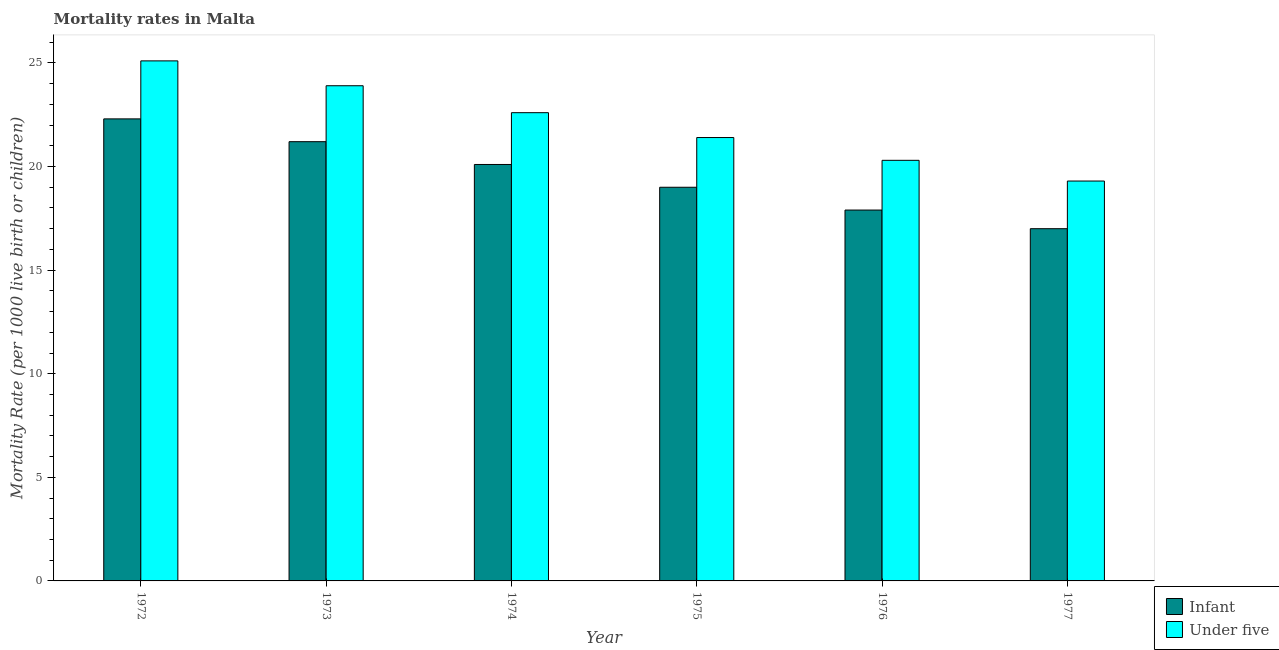How many different coloured bars are there?
Keep it short and to the point. 2. Are the number of bars per tick equal to the number of legend labels?
Provide a succinct answer. Yes. Are the number of bars on each tick of the X-axis equal?
Your answer should be very brief. Yes. How many bars are there on the 1st tick from the left?
Provide a succinct answer. 2. What is the label of the 6th group of bars from the left?
Offer a very short reply. 1977. Across all years, what is the maximum infant mortality rate?
Offer a very short reply. 22.3. Across all years, what is the minimum under-5 mortality rate?
Keep it short and to the point. 19.3. In which year was the infant mortality rate minimum?
Your response must be concise. 1977. What is the total under-5 mortality rate in the graph?
Your response must be concise. 132.6. What is the difference between the under-5 mortality rate in 1973 and that in 1975?
Ensure brevity in your answer.  2.5. What is the difference between the under-5 mortality rate in 1976 and the infant mortality rate in 1972?
Make the answer very short. -4.8. What is the average infant mortality rate per year?
Provide a short and direct response. 19.58. What is the ratio of the under-5 mortality rate in 1975 to that in 1976?
Make the answer very short. 1.05. Is the difference between the under-5 mortality rate in 1973 and 1974 greater than the difference between the infant mortality rate in 1973 and 1974?
Your answer should be very brief. No. What is the difference between the highest and the second highest under-5 mortality rate?
Provide a short and direct response. 1.2. What is the difference between the highest and the lowest infant mortality rate?
Make the answer very short. 5.3. Is the sum of the under-5 mortality rate in 1973 and 1977 greater than the maximum infant mortality rate across all years?
Give a very brief answer. Yes. What does the 2nd bar from the left in 1975 represents?
Offer a terse response. Under five. What does the 1st bar from the right in 1975 represents?
Offer a very short reply. Under five. How many bars are there?
Keep it short and to the point. 12. Are all the bars in the graph horizontal?
Make the answer very short. No. Where does the legend appear in the graph?
Your answer should be very brief. Bottom right. What is the title of the graph?
Provide a succinct answer. Mortality rates in Malta. Does "Techinal cooperation" appear as one of the legend labels in the graph?
Provide a short and direct response. No. What is the label or title of the Y-axis?
Your answer should be very brief. Mortality Rate (per 1000 live birth or children). What is the Mortality Rate (per 1000 live birth or children) in Infant in 1972?
Your response must be concise. 22.3. What is the Mortality Rate (per 1000 live birth or children) in Under five in 1972?
Give a very brief answer. 25.1. What is the Mortality Rate (per 1000 live birth or children) in Infant in 1973?
Keep it short and to the point. 21.2. What is the Mortality Rate (per 1000 live birth or children) in Under five in 1973?
Your answer should be very brief. 23.9. What is the Mortality Rate (per 1000 live birth or children) of Infant in 1974?
Ensure brevity in your answer.  20.1. What is the Mortality Rate (per 1000 live birth or children) in Under five in 1974?
Make the answer very short. 22.6. What is the Mortality Rate (per 1000 live birth or children) of Infant in 1975?
Provide a succinct answer. 19. What is the Mortality Rate (per 1000 live birth or children) of Under five in 1975?
Your answer should be compact. 21.4. What is the Mortality Rate (per 1000 live birth or children) of Under five in 1976?
Provide a succinct answer. 20.3. What is the Mortality Rate (per 1000 live birth or children) in Under five in 1977?
Offer a terse response. 19.3. Across all years, what is the maximum Mortality Rate (per 1000 live birth or children) in Infant?
Give a very brief answer. 22.3. Across all years, what is the maximum Mortality Rate (per 1000 live birth or children) in Under five?
Provide a succinct answer. 25.1. Across all years, what is the minimum Mortality Rate (per 1000 live birth or children) of Infant?
Your answer should be compact. 17. Across all years, what is the minimum Mortality Rate (per 1000 live birth or children) in Under five?
Your answer should be compact. 19.3. What is the total Mortality Rate (per 1000 live birth or children) of Infant in the graph?
Keep it short and to the point. 117.5. What is the total Mortality Rate (per 1000 live birth or children) in Under five in the graph?
Make the answer very short. 132.6. What is the difference between the Mortality Rate (per 1000 live birth or children) of Under five in 1972 and that in 1975?
Offer a very short reply. 3.7. What is the difference between the Mortality Rate (per 1000 live birth or children) in Infant in 1972 and that in 1977?
Ensure brevity in your answer.  5.3. What is the difference between the Mortality Rate (per 1000 live birth or children) in Under five in 1972 and that in 1977?
Give a very brief answer. 5.8. What is the difference between the Mortality Rate (per 1000 live birth or children) of Infant in 1973 and that in 1976?
Make the answer very short. 3.3. What is the difference between the Mortality Rate (per 1000 live birth or children) in Under five in 1973 and that in 1976?
Ensure brevity in your answer.  3.6. What is the difference between the Mortality Rate (per 1000 live birth or children) in Infant in 1973 and that in 1977?
Offer a very short reply. 4.2. What is the difference between the Mortality Rate (per 1000 live birth or children) of Infant in 1974 and that in 1976?
Offer a very short reply. 2.2. What is the difference between the Mortality Rate (per 1000 live birth or children) in Infant in 1974 and that in 1977?
Your answer should be compact. 3.1. What is the difference between the Mortality Rate (per 1000 live birth or children) of Infant in 1975 and that in 1976?
Your answer should be compact. 1.1. What is the difference between the Mortality Rate (per 1000 live birth or children) of Under five in 1975 and that in 1976?
Provide a succinct answer. 1.1. What is the difference between the Mortality Rate (per 1000 live birth or children) of Infant in 1972 and the Mortality Rate (per 1000 live birth or children) of Under five in 1974?
Make the answer very short. -0.3. What is the difference between the Mortality Rate (per 1000 live birth or children) in Infant in 1972 and the Mortality Rate (per 1000 live birth or children) in Under five in 1976?
Offer a very short reply. 2. What is the difference between the Mortality Rate (per 1000 live birth or children) in Infant in 1972 and the Mortality Rate (per 1000 live birth or children) in Under five in 1977?
Your response must be concise. 3. What is the difference between the Mortality Rate (per 1000 live birth or children) in Infant in 1974 and the Mortality Rate (per 1000 live birth or children) in Under five in 1975?
Make the answer very short. -1.3. What is the difference between the Mortality Rate (per 1000 live birth or children) in Infant in 1974 and the Mortality Rate (per 1000 live birth or children) in Under five in 1976?
Offer a terse response. -0.2. What is the difference between the Mortality Rate (per 1000 live birth or children) in Infant in 1975 and the Mortality Rate (per 1000 live birth or children) in Under five in 1976?
Offer a very short reply. -1.3. What is the difference between the Mortality Rate (per 1000 live birth or children) of Infant in 1975 and the Mortality Rate (per 1000 live birth or children) of Under five in 1977?
Ensure brevity in your answer.  -0.3. What is the average Mortality Rate (per 1000 live birth or children) of Infant per year?
Keep it short and to the point. 19.58. What is the average Mortality Rate (per 1000 live birth or children) of Under five per year?
Ensure brevity in your answer.  22.1. In the year 1974, what is the difference between the Mortality Rate (per 1000 live birth or children) of Infant and Mortality Rate (per 1000 live birth or children) of Under five?
Your answer should be very brief. -2.5. What is the ratio of the Mortality Rate (per 1000 live birth or children) in Infant in 1972 to that in 1973?
Your answer should be compact. 1.05. What is the ratio of the Mortality Rate (per 1000 live birth or children) of Under five in 1972 to that in 1973?
Your answer should be compact. 1.05. What is the ratio of the Mortality Rate (per 1000 live birth or children) in Infant in 1972 to that in 1974?
Make the answer very short. 1.11. What is the ratio of the Mortality Rate (per 1000 live birth or children) of Under five in 1972 to that in 1974?
Give a very brief answer. 1.11. What is the ratio of the Mortality Rate (per 1000 live birth or children) of Infant in 1972 to that in 1975?
Ensure brevity in your answer.  1.17. What is the ratio of the Mortality Rate (per 1000 live birth or children) in Under five in 1972 to that in 1975?
Offer a terse response. 1.17. What is the ratio of the Mortality Rate (per 1000 live birth or children) in Infant in 1972 to that in 1976?
Your answer should be compact. 1.25. What is the ratio of the Mortality Rate (per 1000 live birth or children) of Under five in 1972 to that in 1976?
Your answer should be very brief. 1.24. What is the ratio of the Mortality Rate (per 1000 live birth or children) of Infant in 1972 to that in 1977?
Your answer should be compact. 1.31. What is the ratio of the Mortality Rate (per 1000 live birth or children) in Under five in 1972 to that in 1977?
Your answer should be very brief. 1.3. What is the ratio of the Mortality Rate (per 1000 live birth or children) in Infant in 1973 to that in 1974?
Your answer should be compact. 1.05. What is the ratio of the Mortality Rate (per 1000 live birth or children) of Under five in 1973 to that in 1974?
Offer a very short reply. 1.06. What is the ratio of the Mortality Rate (per 1000 live birth or children) of Infant in 1973 to that in 1975?
Provide a succinct answer. 1.12. What is the ratio of the Mortality Rate (per 1000 live birth or children) of Under five in 1973 to that in 1975?
Offer a very short reply. 1.12. What is the ratio of the Mortality Rate (per 1000 live birth or children) of Infant in 1973 to that in 1976?
Make the answer very short. 1.18. What is the ratio of the Mortality Rate (per 1000 live birth or children) of Under five in 1973 to that in 1976?
Offer a terse response. 1.18. What is the ratio of the Mortality Rate (per 1000 live birth or children) of Infant in 1973 to that in 1977?
Keep it short and to the point. 1.25. What is the ratio of the Mortality Rate (per 1000 live birth or children) in Under five in 1973 to that in 1977?
Offer a terse response. 1.24. What is the ratio of the Mortality Rate (per 1000 live birth or children) in Infant in 1974 to that in 1975?
Your response must be concise. 1.06. What is the ratio of the Mortality Rate (per 1000 live birth or children) in Under five in 1974 to that in 1975?
Offer a terse response. 1.06. What is the ratio of the Mortality Rate (per 1000 live birth or children) of Infant in 1974 to that in 1976?
Keep it short and to the point. 1.12. What is the ratio of the Mortality Rate (per 1000 live birth or children) in Under five in 1974 to that in 1976?
Make the answer very short. 1.11. What is the ratio of the Mortality Rate (per 1000 live birth or children) in Infant in 1974 to that in 1977?
Ensure brevity in your answer.  1.18. What is the ratio of the Mortality Rate (per 1000 live birth or children) in Under five in 1974 to that in 1977?
Provide a succinct answer. 1.17. What is the ratio of the Mortality Rate (per 1000 live birth or children) in Infant in 1975 to that in 1976?
Your answer should be very brief. 1.06. What is the ratio of the Mortality Rate (per 1000 live birth or children) of Under five in 1975 to that in 1976?
Your answer should be very brief. 1.05. What is the ratio of the Mortality Rate (per 1000 live birth or children) in Infant in 1975 to that in 1977?
Your response must be concise. 1.12. What is the ratio of the Mortality Rate (per 1000 live birth or children) of Under five in 1975 to that in 1977?
Offer a terse response. 1.11. What is the ratio of the Mortality Rate (per 1000 live birth or children) in Infant in 1976 to that in 1977?
Your answer should be very brief. 1.05. What is the ratio of the Mortality Rate (per 1000 live birth or children) of Under five in 1976 to that in 1977?
Your answer should be very brief. 1.05. What is the difference between the highest and the lowest Mortality Rate (per 1000 live birth or children) of Under five?
Keep it short and to the point. 5.8. 